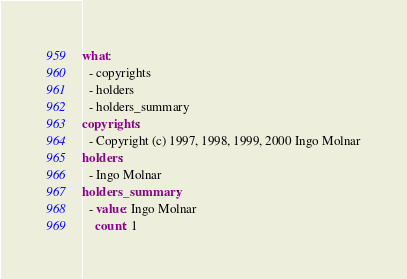<code> <loc_0><loc_0><loc_500><loc_500><_YAML_>what:
  - copyrights
  - holders
  - holders_summary
copyrights:
  - Copyright (c) 1997, 1998, 1999, 2000 Ingo Molnar
holders:
  - Ingo Molnar
holders_summary:
  - value: Ingo Molnar
    count: 1
</code> 